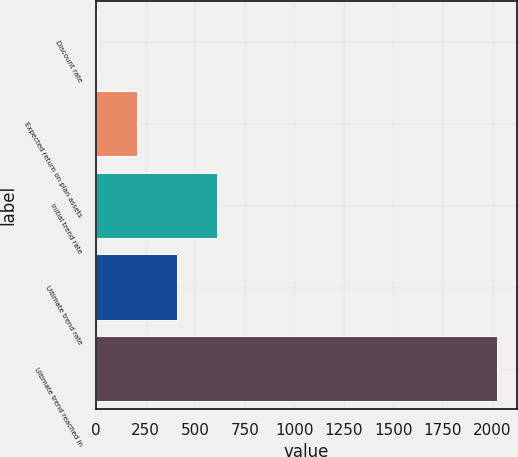Convert chart to OTSL. <chart><loc_0><loc_0><loc_500><loc_500><bar_chart><fcel>Discount rate<fcel>Expected return on plan assets<fcel>Initial trend rate<fcel>Ultimate trend rate<fcel>Ultimate trend reached in<nl><fcel>4.43<fcel>205.99<fcel>609.11<fcel>407.55<fcel>2020<nl></chart> 